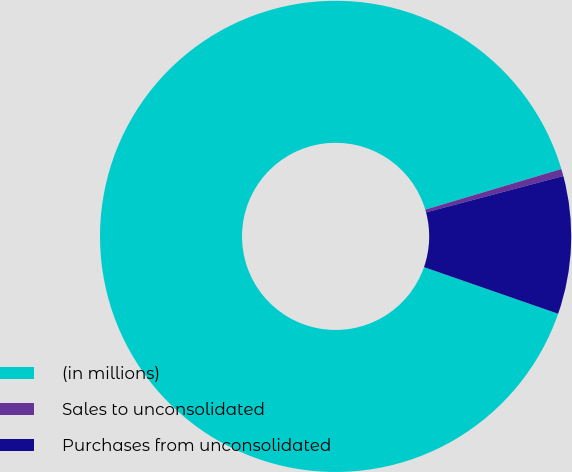Convert chart. <chart><loc_0><loc_0><loc_500><loc_500><pie_chart><fcel>(in millions)<fcel>Sales to unconsolidated<fcel>Purchases from unconsolidated<nl><fcel>90.06%<fcel>0.49%<fcel>9.45%<nl></chart> 